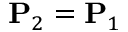Convert formula to latex. <formula><loc_0><loc_0><loc_500><loc_500>P _ { 2 } = P _ { 1 }</formula> 